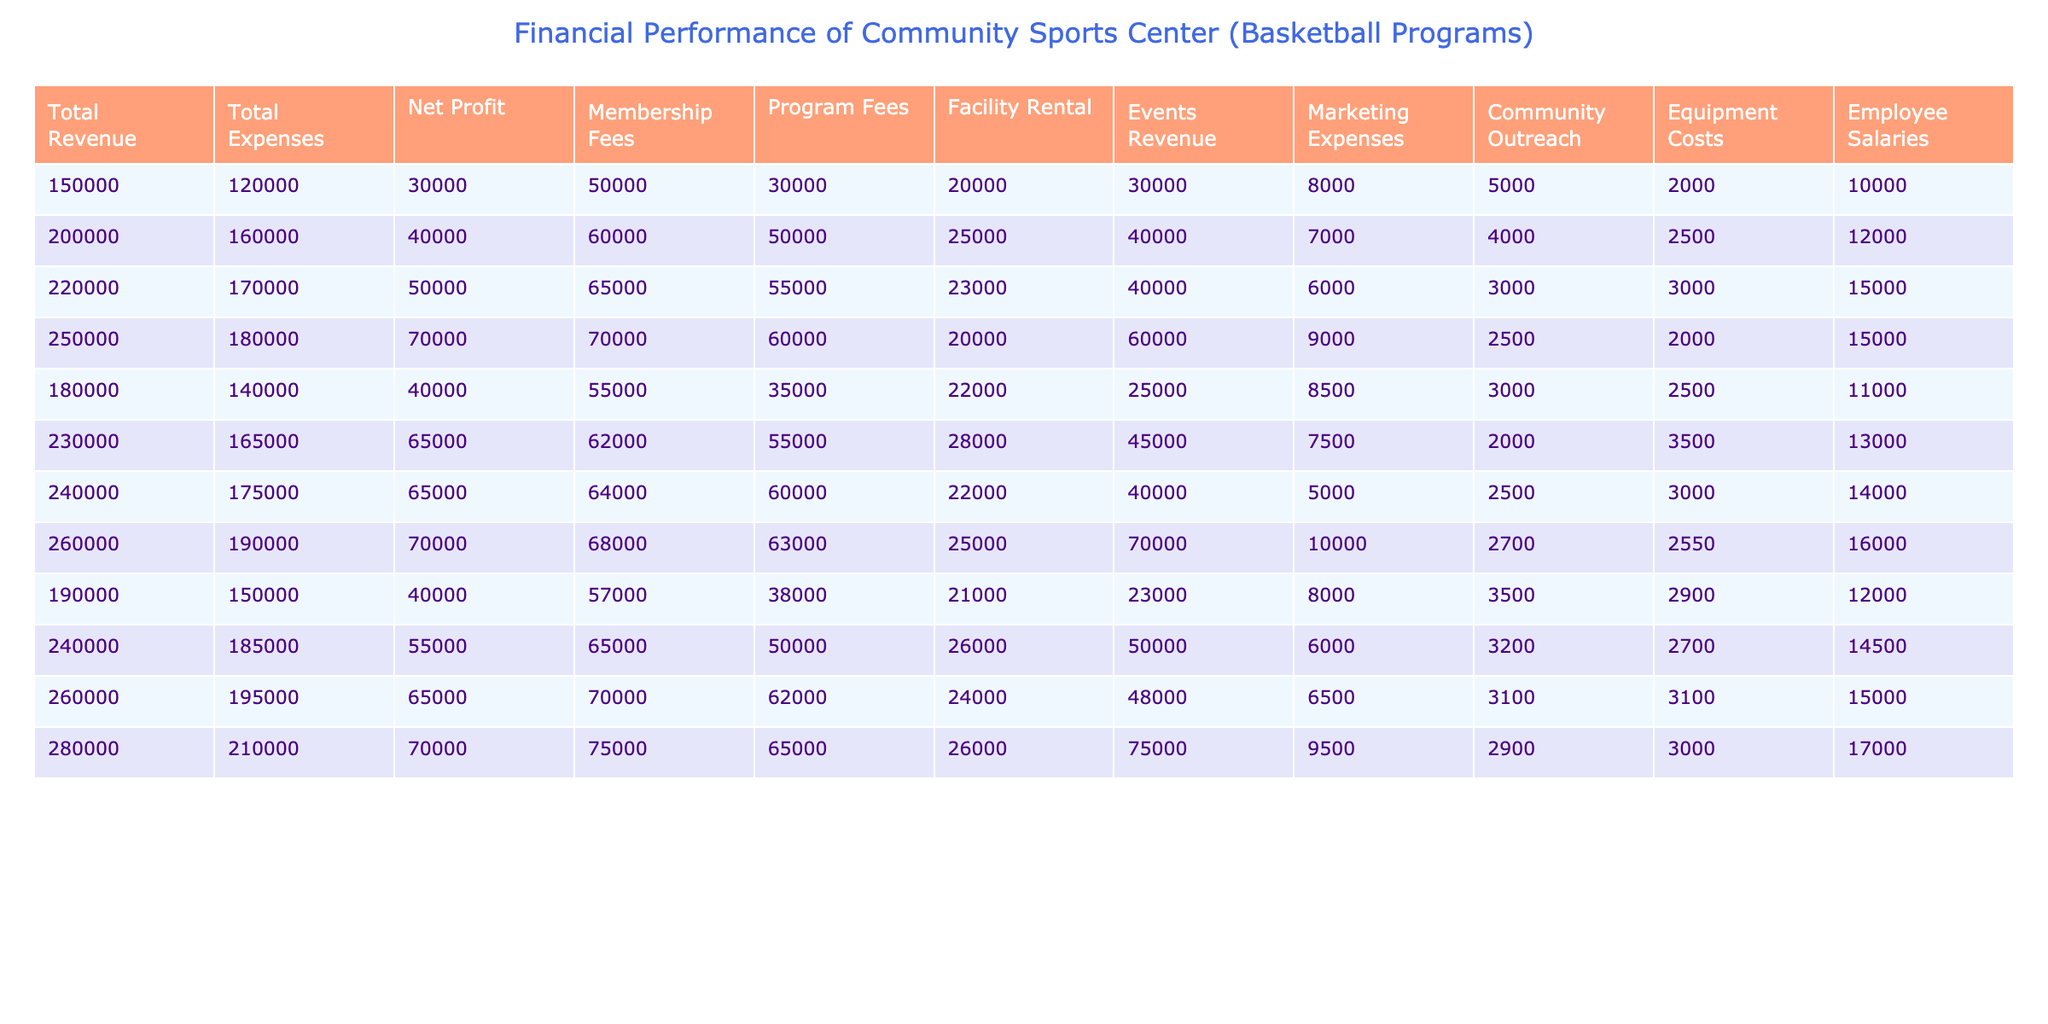What was the total revenue in Q4 of 2022? In the table, locate the row for Q4 of 2022 and find the value under the "Total Revenue" column, which is 260000.
Answer: 260000 What was the net profit for the first quarter of 2023? Look at the row for Q1 of 2023 and find the value in the "Net Profit" column, which is 40000.
Answer: 40000 What are the total expenses for the entire year of 2022? You need to sum the expenses for each quarter in 2022: 140000 + 165000 + 175000 + 190000 = 670000.
Answer: 670000 In which quarter of 2021 did the sports center have the highest net profit? Examine the "Net Profit" column for each quarter in 2021: Q1 = 30000, Q2 = 40000, Q3 = 50000, Q4 = 70000. Q4 had the highest profit of 70000.
Answer: Q4 2021 Did the community sports center's total revenue exceed total expenses in Q2 of 2023? For Q2 of 2023, total revenue is 240000 and total expenses are 185000. Since 240000 > 185000, it is true that revenue exceeded expenses.
Answer: Yes What was the average facility rental income over the years 2021 and 2022? Sum the facility rental income for 2021 (20000 + 25000 + 23000 + 20000) = 88000, for 2022 (22000 + 28000 + 22000 + 25000) = 97000. The total is 88000 + 97000 = 185000. The average is 185000 / 8 = 23125.
Answer: 23125 What was the total employee salaries cost for the last quarter of 2021? In the row for Q4 of 2021, the "Employee Salaries" column shows the value of 15000.
Answer: 15000 Which quarter had the highest marketing expenses in 2023? Comparing that row for each quarter in 2023: Q1 = 8000, Q2 = 6000, Q3 = 6500, Q4 = 9500, Q4 has the highest marketing expenses of 9500.
Answer: Q4 2023 What was the percentage increase in total revenue from Q1 to Q2 in 2023? Calculate the difference between Q2 and Q1 total revenue (240000 - 190000 = 50000). Then calculate the percentage increase: (50000 / 190000) * 100 = 26.32%.
Answer: 26.32% How much more did membership fees contribute to revenue in 2022 compared to 2021? Sum the membership fees for 2021 (50000 + 60000 + 65000 + 70000) = 295000, and for 2022 (55000 + 62000 + 64000 + 68000) = 249000. The difference is 295000 - 249000 = 46000.
Answer: 46000 